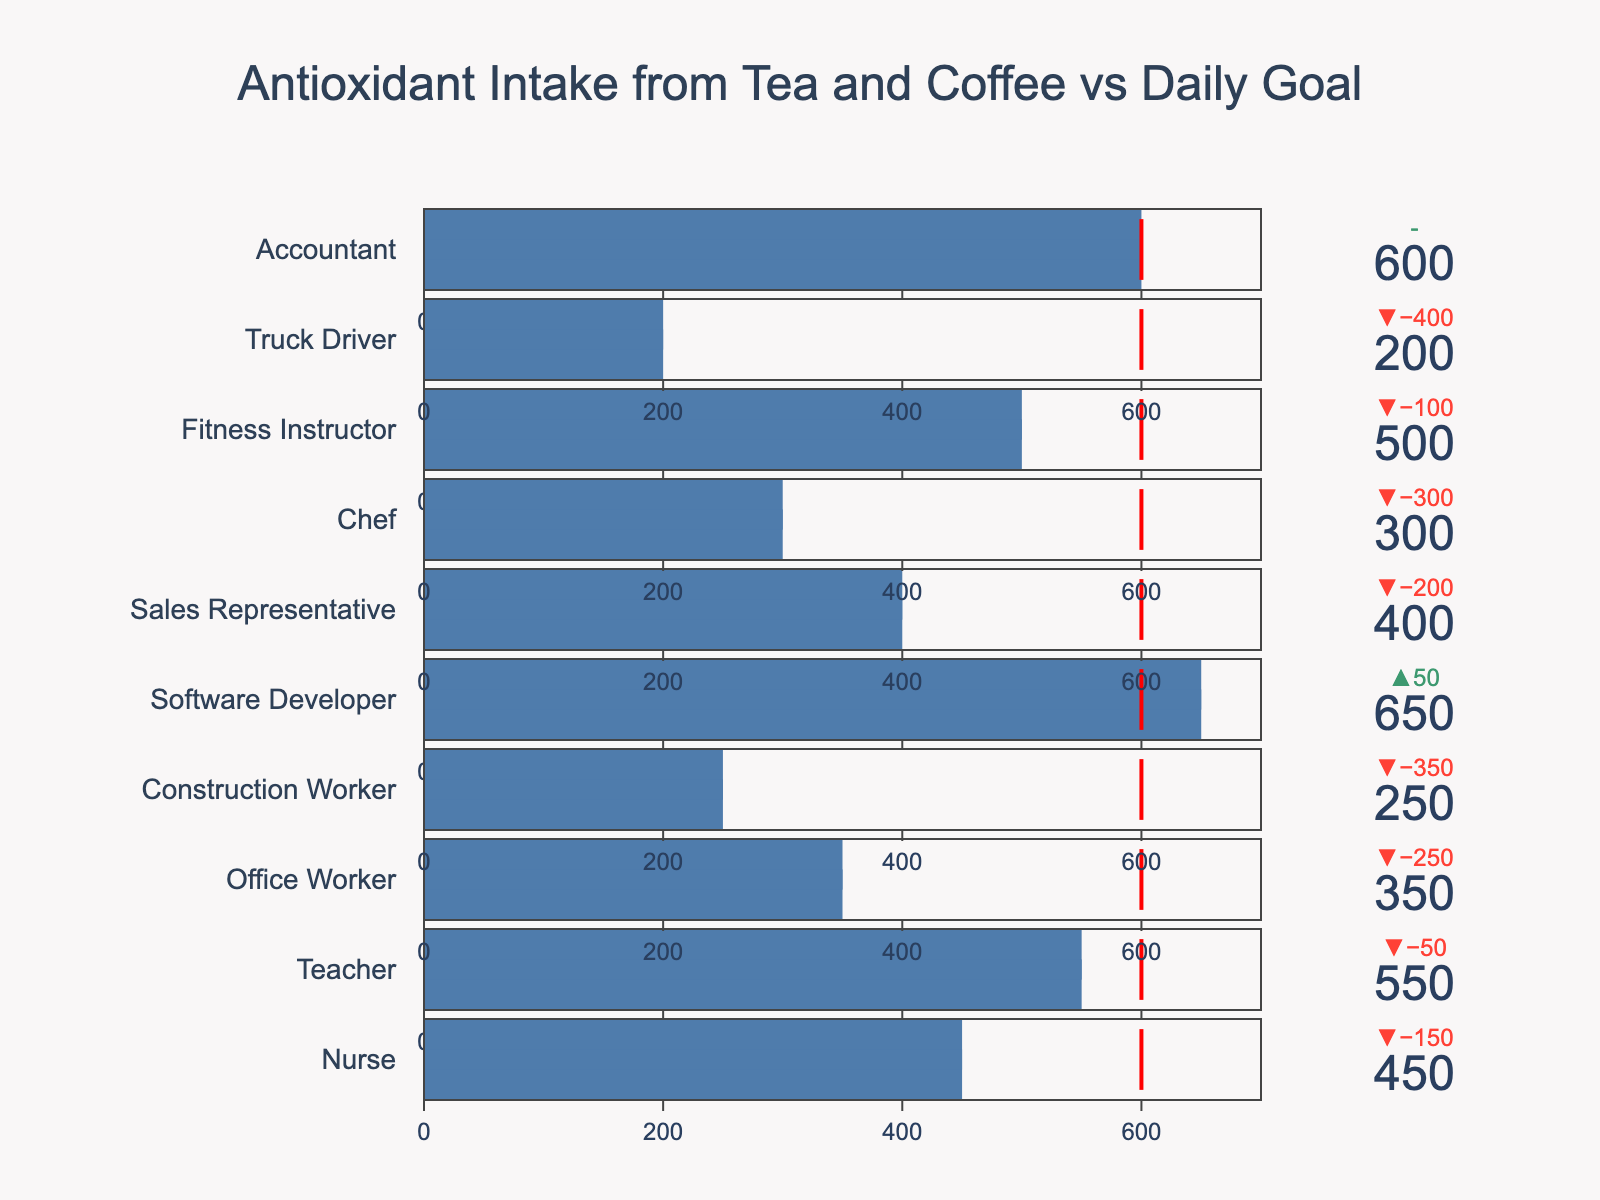What's the title of the figure? Look at the top and center of the figure to find the title. It is typically in a larger font size and distinct color.
Answer: Antioxidant Intake from Tea and Coffee vs Daily Goal How many occupations have an antioxidant intake below the daily goal? Compare each occupation's antioxidant intake with the daily goal of 600 mg. Count how many have an intake less than 600 mg.
Answer: 7 Which occupation has the highest antioxidant intake? Identify the occupation with the bullet chart bar reaching the highest value on the x-axis.
Answer: Software Developer By how much does the office worker's antioxidant intake fall short of the daily goal? Subtract the Office Worker's antioxidant intake (350 mg) from their daily goal (600 mg) to find the difference.
Answer: 250 mg What is the median antioxidant intake among all occupations? Arrange the intakes in numerical order and find the middle value. If the number of intakes is even, calculate the average of the two middle numbers.
Answer: 400 mg How many occupations meet or exceed their daily antioxidant goal? Compare each occupation's antioxidant intake with the daily goal and count those with intake values equal to or greater than 600 mg.
Answer: 3 Which occupation has the lowest antioxidant intake? Identify the occupation with the bullet chart bar reaching the lowest value on the x-axis.
Answer: Truck Driver What's the difference in antioxidant intake between the teacher and the chef? Subtract the antioxidant intake of the Chef (300 mg) from that of the Teacher (550 mg).
Answer: 250 mg Which occupation's antioxidant intake is exactly equal to the daily goal? Identify if any occupation's bullet chart bar reaches exactly 600 mg, which is the daily goal.
Answer: Accountant Based on the bullet chart, do more occupations fall short of the daily goal or meet/exceed it? Count the number of occupations that fall short and those that meet/exceed the daily goal, then compare the counts.
Answer: Fall short 